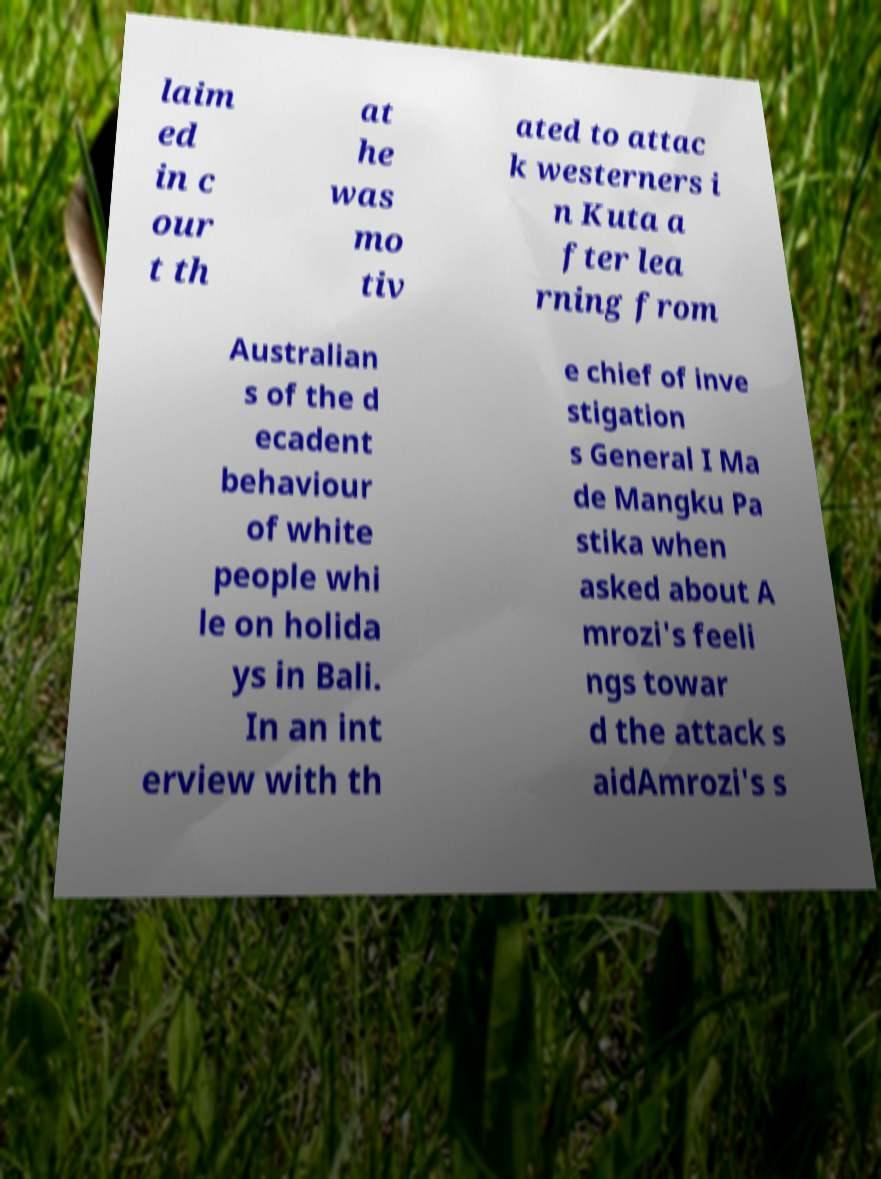For documentation purposes, I need the text within this image transcribed. Could you provide that? laim ed in c our t th at he was mo tiv ated to attac k westerners i n Kuta a fter lea rning from Australian s of the d ecadent behaviour of white people whi le on holida ys in Bali. In an int erview with th e chief of inve stigation s General I Ma de Mangku Pa stika when asked about A mrozi's feeli ngs towar d the attack s aidAmrozi's s 